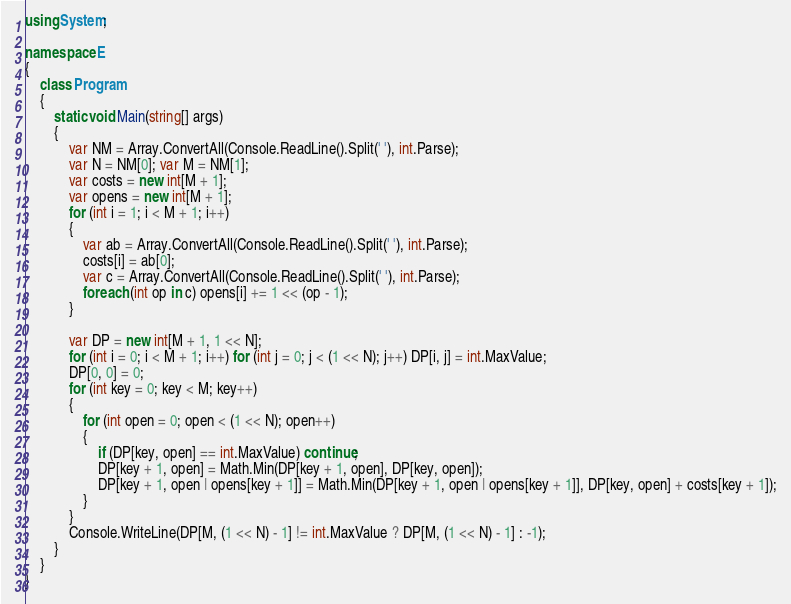<code> <loc_0><loc_0><loc_500><loc_500><_C#_>using System;

namespace E
{
    class Program
    {
        static void Main(string[] args)
        {
            var NM = Array.ConvertAll(Console.ReadLine().Split(' '), int.Parse);
            var N = NM[0]; var M = NM[1];
            var costs = new int[M + 1];
            var opens = new int[M + 1];
            for (int i = 1; i < M + 1; i++)
            {
                var ab = Array.ConvertAll(Console.ReadLine().Split(' '), int.Parse);
                costs[i] = ab[0];
                var c = Array.ConvertAll(Console.ReadLine().Split(' '), int.Parse);
                foreach (int op in c) opens[i] += 1 << (op - 1);
            }

            var DP = new int[M + 1, 1 << N];
            for (int i = 0; i < M + 1; i++) for (int j = 0; j < (1 << N); j++) DP[i, j] = int.MaxValue;
            DP[0, 0] = 0;
            for (int key = 0; key < M; key++)
            {
                for (int open = 0; open < (1 << N); open++)
                {
                    if (DP[key, open] == int.MaxValue) continue;
                    DP[key + 1, open] = Math.Min(DP[key + 1, open], DP[key, open]);
                    DP[key + 1, open | opens[key + 1]] = Math.Min(DP[key + 1, open | opens[key + 1]], DP[key, open] + costs[key + 1]);
                }
            }
            Console.WriteLine(DP[M, (1 << N) - 1] != int.MaxValue ? DP[M, (1 << N) - 1] : -1);
        }
    }
}
</code> 